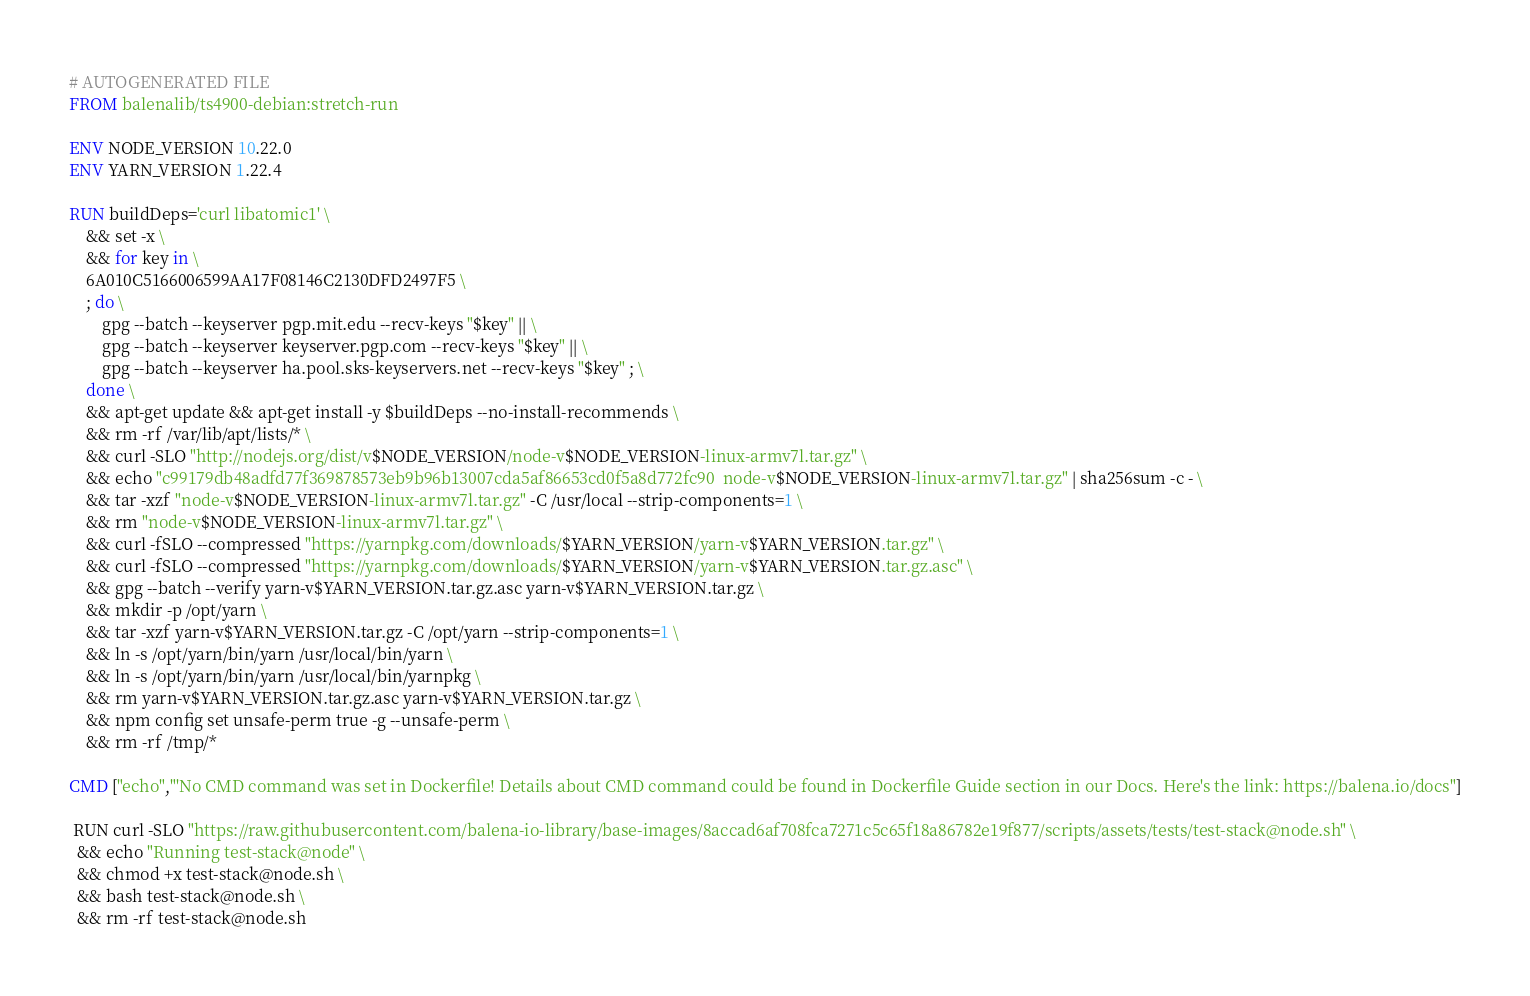<code> <loc_0><loc_0><loc_500><loc_500><_Dockerfile_># AUTOGENERATED FILE
FROM balenalib/ts4900-debian:stretch-run

ENV NODE_VERSION 10.22.0
ENV YARN_VERSION 1.22.4

RUN buildDeps='curl libatomic1' \
	&& set -x \
	&& for key in \
	6A010C5166006599AA17F08146C2130DFD2497F5 \
	; do \
		gpg --batch --keyserver pgp.mit.edu --recv-keys "$key" || \
		gpg --batch --keyserver keyserver.pgp.com --recv-keys "$key" || \
		gpg --batch --keyserver ha.pool.sks-keyservers.net --recv-keys "$key" ; \
	done \
	&& apt-get update && apt-get install -y $buildDeps --no-install-recommends \
	&& rm -rf /var/lib/apt/lists/* \
	&& curl -SLO "http://nodejs.org/dist/v$NODE_VERSION/node-v$NODE_VERSION-linux-armv7l.tar.gz" \
	&& echo "c99179db48adfd77f369878573eb9b96b13007cda5af86653cd0f5a8d772fc90  node-v$NODE_VERSION-linux-armv7l.tar.gz" | sha256sum -c - \
	&& tar -xzf "node-v$NODE_VERSION-linux-armv7l.tar.gz" -C /usr/local --strip-components=1 \
	&& rm "node-v$NODE_VERSION-linux-armv7l.tar.gz" \
	&& curl -fSLO --compressed "https://yarnpkg.com/downloads/$YARN_VERSION/yarn-v$YARN_VERSION.tar.gz" \
	&& curl -fSLO --compressed "https://yarnpkg.com/downloads/$YARN_VERSION/yarn-v$YARN_VERSION.tar.gz.asc" \
	&& gpg --batch --verify yarn-v$YARN_VERSION.tar.gz.asc yarn-v$YARN_VERSION.tar.gz \
	&& mkdir -p /opt/yarn \
	&& tar -xzf yarn-v$YARN_VERSION.tar.gz -C /opt/yarn --strip-components=1 \
	&& ln -s /opt/yarn/bin/yarn /usr/local/bin/yarn \
	&& ln -s /opt/yarn/bin/yarn /usr/local/bin/yarnpkg \
	&& rm yarn-v$YARN_VERSION.tar.gz.asc yarn-v$YARN_VERSION.tar.gz \
	&& npm config set unsafe-perm true -g --unsafe-perm \
	&& rm -rf /tmp/*

CMD ["echo","'No CMD command was set in Dockerfile! Details about CMD command could be found in Dockerfile Guide section in our Docs. Here's the link: https://balena.io/docs"]

 RUN curl -SLO "https://raw.githubusercontent.com/balena-io-library/base-images/8accad6af708fca7271c5c65f18a86782e19f877/scripts/assets/tests/test-stack@node.sh" \
  && echo "Running test-stack@node" \
  && chmod +x test-stack@node.sh \
  && bash test-stack@node.sh \
  && rm -rf test-stack@node.sh 
</code> 